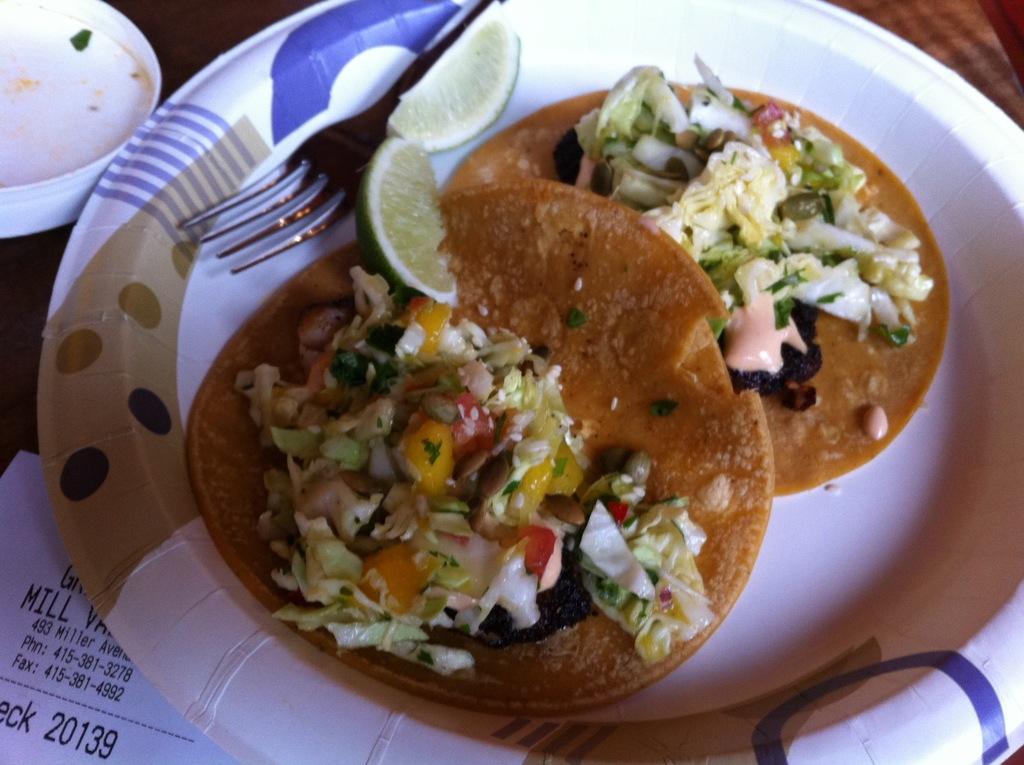Describe this image in one or two sentences. In this image we can see a plate of food items on the table. We can also see the fork, bill paper and also the white color box on the left. 